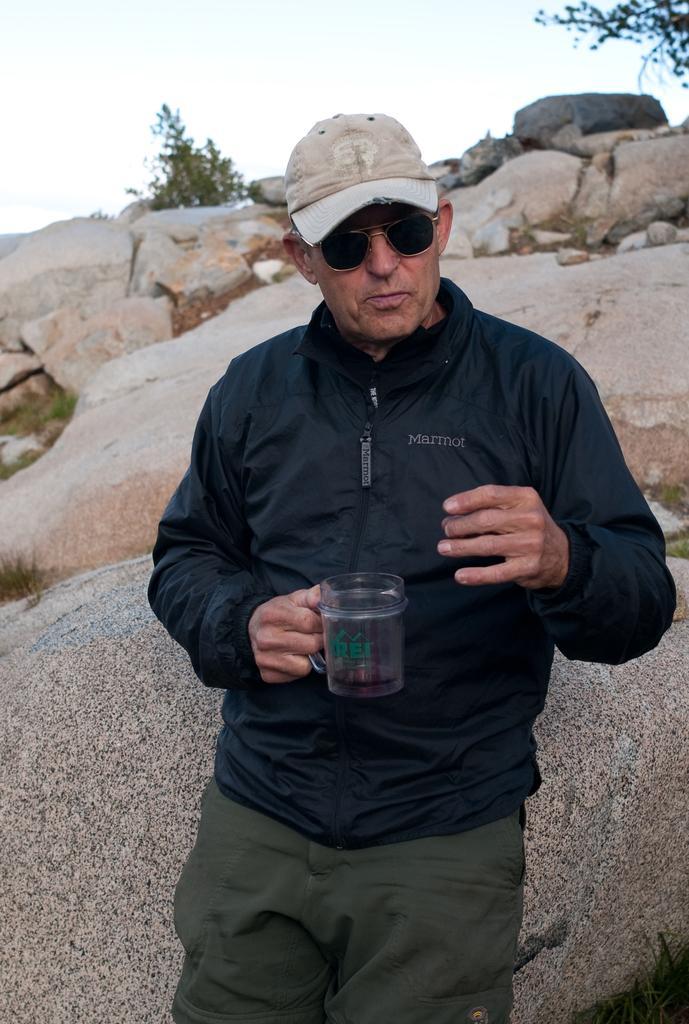Describe this image in one or two sentences. In this picture we can observe a person wearing black color jacket and holding a cup in his hand. Behind him there are some rocks. We can observe some plants. In the background there is a sky. 